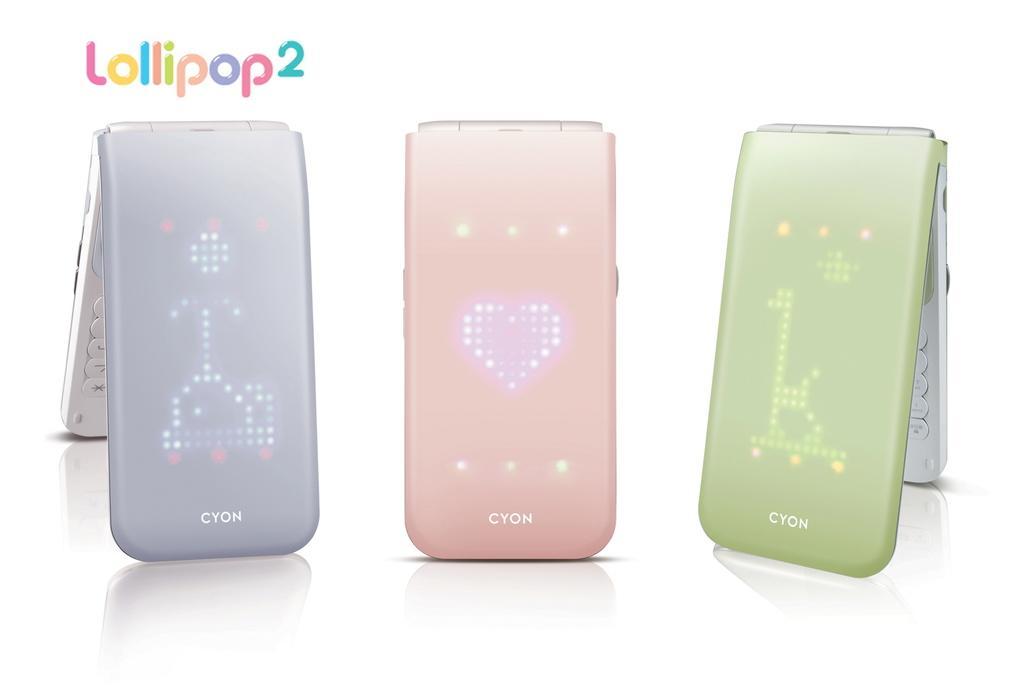Can you describe this image briefly? In this picture there are devices. At the top there is text. At the bottom it looks like a table and their reflections of device on the table and there is text on the devices. 